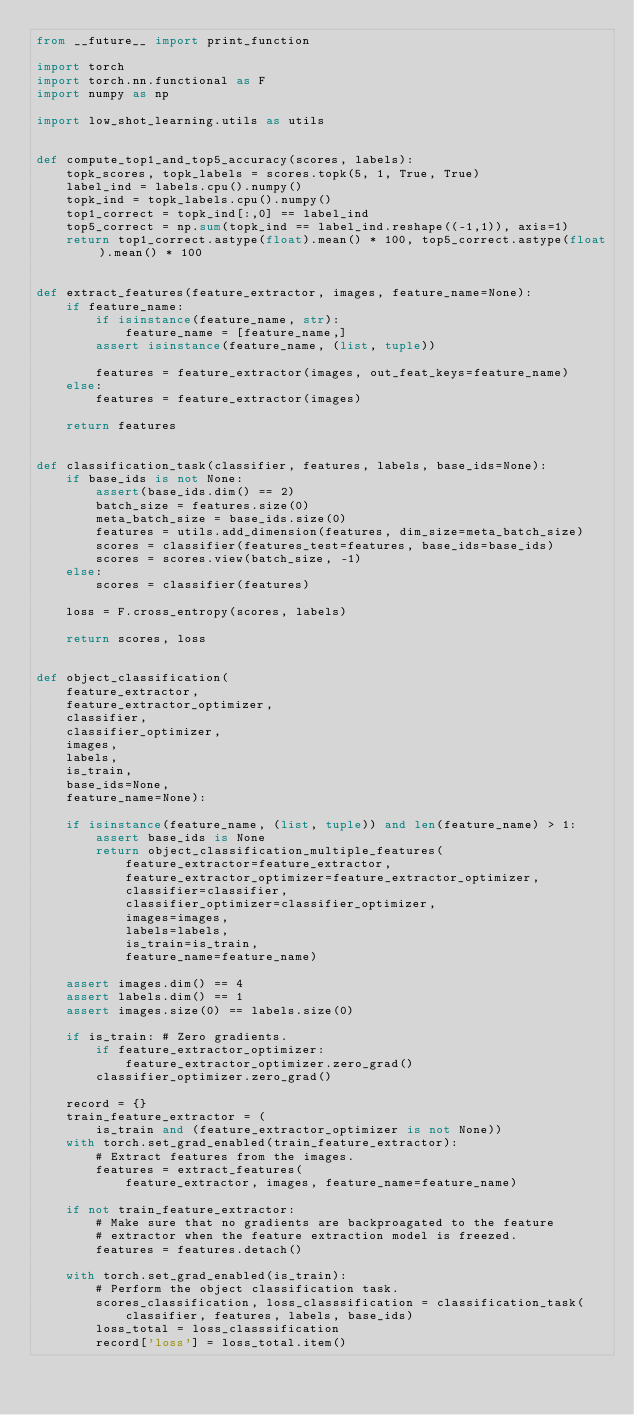Convert code to text. <code><loc_0><loc_0><loc_500><loc_500><_Python_>from __future__ import print_function

import torch
import torch.nn.functional as F
import numpy as np

import low_shot_learning.utils as utils


def compute_top1_and_top5_accuracy(scores, labels):
    topk_scores, topk_labels = scores.topk(5, 1, True, True)
    label_ind = labels.cpu().numpy()
    topk_ind = topk_labels.cpu().numpy()
    top1_correct = topk_ind[:,0] == label_ind
    top5_correct = np.sum(topk_ind == label_ind.reshape((-1,1)), axis=1)
    return top1_correct.astype(float).mean() * 100, top5_correct.astype(float).mean() * 100


def extract_features(feature_extractor, images, feature_name=None):
    if feature_name:
        if isinstance(feature_name, str):
            feature_name = [feature_name,]
        assert isinstance(feature_name, (list, tuple))

        features = feature_extractor(images, out_feat_keys=feature_name)
    else:
        features = feature_extractor(images)

    return features


def classification_task(classifier, features, labels, base_ids=None):
    if base_ids is not None:
        assert(base_ids.dim() == 2)
        batch_size = features.size(0)
        meta_batch_size = base_ids.size(0)
        features = utils.add_dimension(features, dim_size=meta_batch_size)
        scores = classifier(features_test=features, base_ids=base_ids)
        scores = scores.view(batch_size, -1)
    else:
        scores = classifier(features)

    loss = F.cross_entropy(scores, labels)

    return scores, loss


def object_classification(
    feature_extractor,
    feature_extractor_optimizer,
    classifier,
    classifier_optimizer,
    images,
    labels,
    is_train,
    base_ids=None,
    feature_name=None):

    if isinstance(feature_name, (list, tuple)) and len(feature_name) > 1:
        assert base_ids is None
        return object_classification_multiple_features(
            feature_extractor=feature_extractor,
            feature_extractor_optimizer=feature_extractor_optimizer,
            classifier=classifier,
            classifier_optimizer=classifier_optimizer,
            images=images,
            labels=labels,
            is_train=is_train,
            feature_name=feature_name)

    assert images.dim() == 4
    assert labels.dim() == 1
    assert images.size(0) == labels.size(0)

    if is_train: # Zero gradients.
        if feature_extractor_optimizer:
            feature_extractor_optimizer.zero_grad()
        classifier_optimizer.zero_grad()

    record = {}
    train_feature_extractor = (
        is_train and (feature_extractor_optimizer is not None))
    with torch.set_grad_enabled(train_feature_extractor):
        # Extract features from the images.
        features = extract_features(
            feature_extractor, images, feature_name=feature_name)

    if not train_feature_extractor:
        # Make sure that no gradients are backproagated to the feature
        # extractor when the feature extraction model is freezed.
        features = features.detach()

    with torch.set_grad_enabled(is_train):
        # Perform the object classification task.
        scores_classification, loss_classsification = classification_task(
            classifier, features, labels, base_ids)
        loss_total = loss_classsification
        record['loss'] = loss_total.item()
</code> 